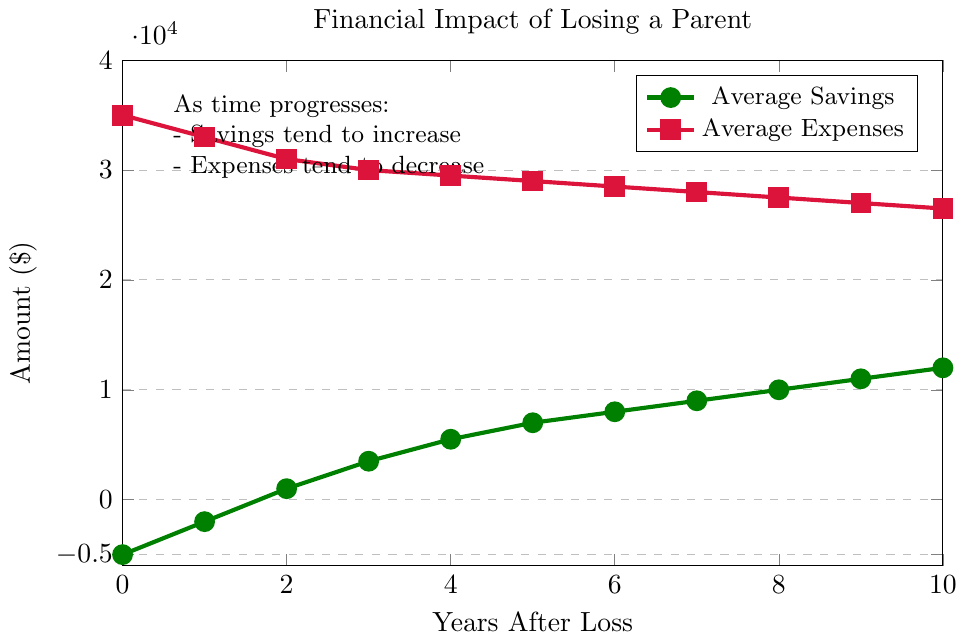What's the average savings at year 5? Locate the savings value on the chart for year 5, which is $7000. This is the average savings at year 5.
Answer: 7000 How much did expenses decrease from year 0 to year 5? Locate the expense values at year 0 and year 5 from the chart. Expenses at year 0 are $35000 and at year 5 are $29000. Calculate the difference: $35000 - $29000 = $6000.
Answer: 6000 In the first five years, which year had the highest expenses? Look at the expenses data points from years 0 to 5 on the chart. The highest expense value is at year 0 with $35000.
Answer: Year 0 When did the average savings exceed $0 for the first time? Observe the point where the savings cross the x-axis (becomes positive). This happens between year 1 and year 2, at year 2.
Answer: Year 2 What is the difference in savings between year 3 and year 8? Check the savings values at year 3 and year 8 from the chart. At year 3, savings are $3500, and at year 8, they are $10000. Calculate the difference: $10000 - $3500 = $6500.
Answer: 6500 Which year shows a more significant decrease in average expenses: from year 0 to year 1 or from year 4 to year 5? Calculate the decrease in expenses for both periods. For year 0 to year 1: $35000 - $33000 = $2000. For year 4 to year 5: $29500 - $29000 = $500. The decrease is greater from year 0 to year 1.
Answer: Year 0 to Year 1 How does the trend in average savings compare to the trend in average expenses over the ten years? Observe the overall trend lines for both savings and expenses. Savings consistently increase each year, while expenses consistently decrease each year.
Answer: Savings increase, expenses decrease Which color represents average expenses in the chart? Identify the color associated with the expenses line marked with square points. It is red.
Answer: Red What is the total increase in average savings from year 0 to year 10? Find the savings values at year 0 and year 10 and calculate the total increase: $12000 - (-$5000) = $17000.
Answer: 17000 